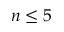<formula> <loc_0><loc_0><loc_500><loc_500>n \leq 5</formula> 